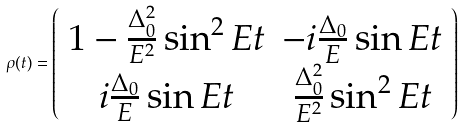<formula> <loc_0><loc_0><loc_500><loc_500>\rho ( t ) = \left ( \begin{array} { c c } 1 - \frac { \Delta _ { 0 } ^ { 2 } } { E ^ { 2 } } \sin ^ { 2 } E t & - i \frac { \Delta _ { 0 } } { E } \sin E t \\ i \frac { \Delta _ { 0 } } { E } \sin E t & \frac { \Delta _ { 0 } ^ { 2 } } { E ^ { 2 } } \sin ^ { 2 } E t \end{array} \right )</formula> 